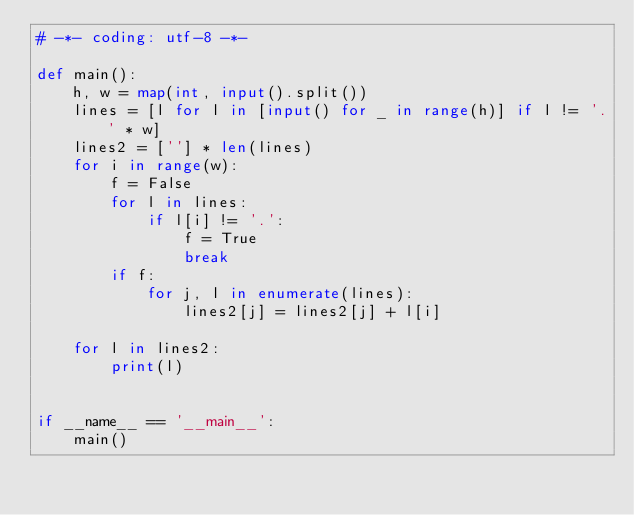Convert code to text. <code><loc_0><loc_0><loc_500><loc_500><_Python_># -*- coding: utf-8 -*-

def main():
    h, w = map(int, input().split())
    lines = [l for l in [input() for _ in range(h)] if l != '.' * w]
    lines2 = [''] * len(lines)
    for i in range(w):
        f = False
        for l in lines:
            if l[i] != '.':
                f = True
                break
        if f:
            for j, l in enumerate(lines):
                lines2[j] = lines2[j] + l[i]

    for l in lines2:
        print(l)


if __name__ == '__main__':
    main()
</code> 